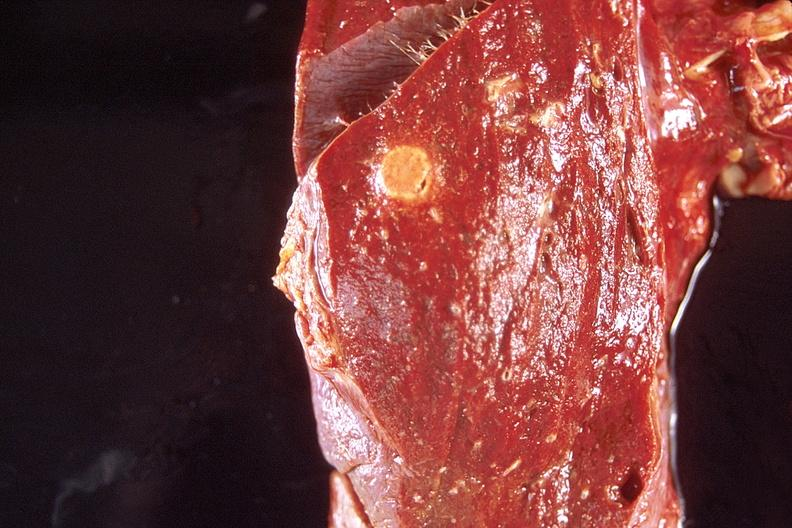what does this image show?
Answer the question using a single word or phrase. Lung 